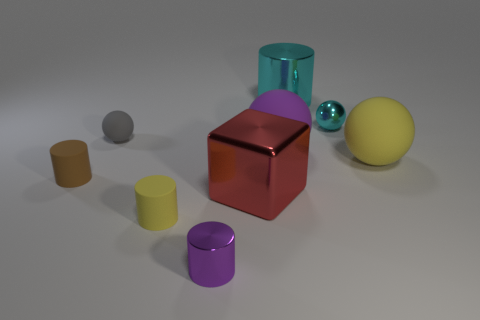What material is the yellow cylinder that is the same size as the brown cylinder?
Your answer should be very brief. Rubber. Is there a large thing made of the same material as the tiny brown cylinder?
Offer a very short reply. Yes. Is the number of large purple rubber balls that are in front of the big yellow sphere less than the number of yellow rubber cylinders?
Your answer should be very brief. Yes. What is the material of the large thing that is left of the purple object behind the small purple cylinder?
Your answer should be compact. Metal. There is a metallic object that is behind the small gray rubber ball and in front of the cyan shiny cylinder; what is its shape?
Keep it short and to the point. Sphere. What number of other objects are there of the same color as the tiny shiny cylinder?
Make the answer very short. 1. How many objects are either rubber balls that are right of the yellow matte cylinder or large cylinders?
Provide a succinct answer. 3. Do the big block and the big matte object on the left side of the large cylinder have the same color?
Offer a terse response. No. Are there any other things that have the same size as the purple metal thing?
Ensure brevity in your answer.  Yes. There is a cylinder behind the matte cylinder that is behind the tiny yellow thing; how big is it?
Provide a succinct answer. Large. 